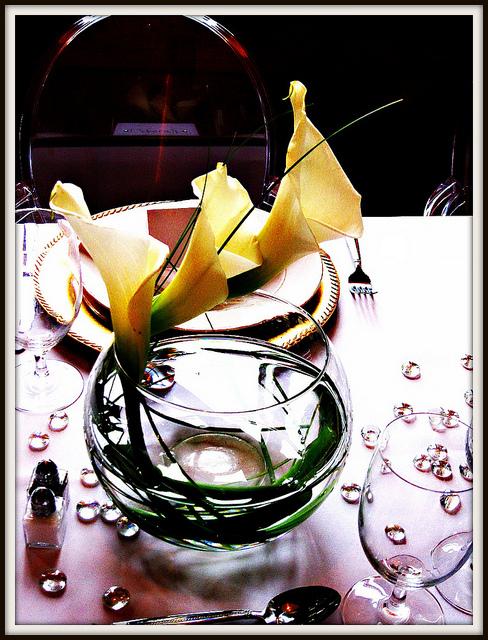What is inside the glass cubes?
Give a very brief answer. Water. What is round on table?
Be succinct. Vase. What color are the flowers?
Concise answer only. Yellow. Where are the water bottles?
Quick response, please. Not here. 